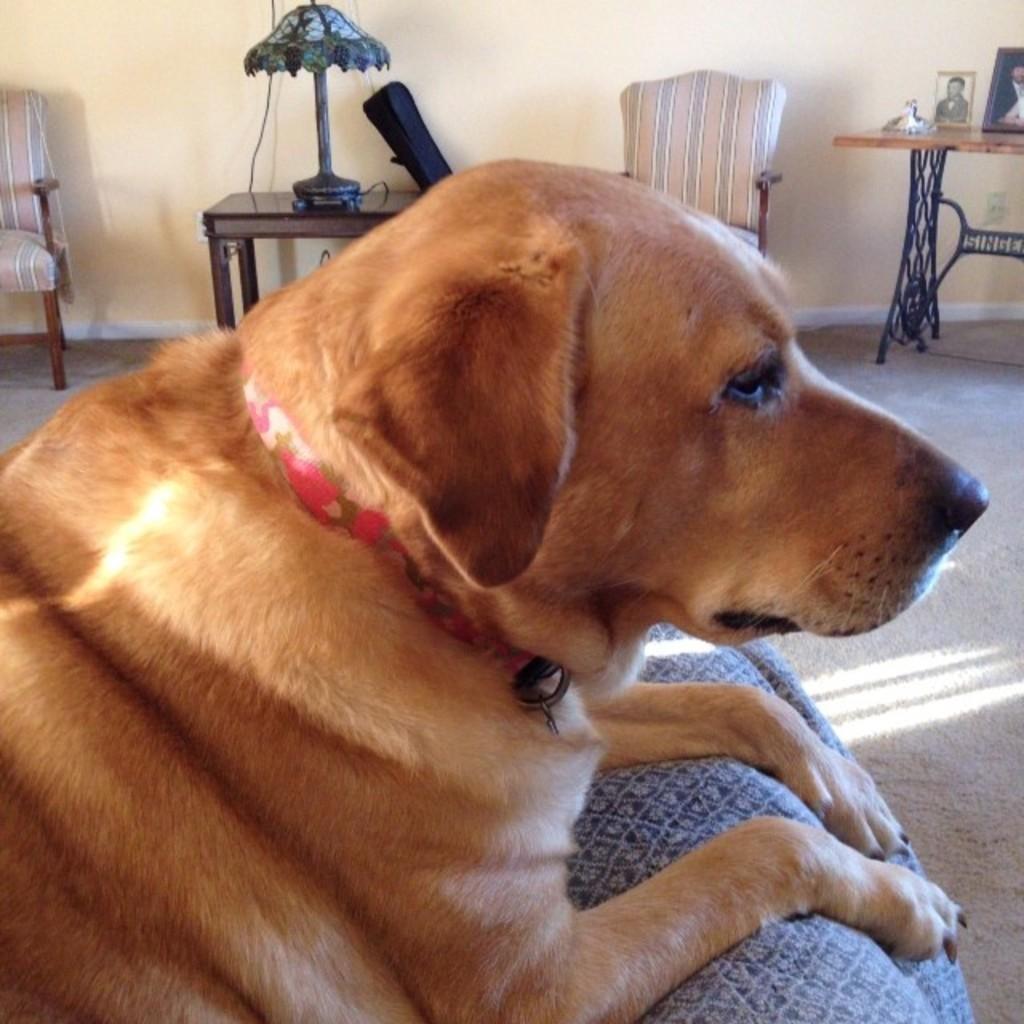Describe this image in one or two sentences. In this image we can see a dog on couch. In the background we can see chairs, table, lamp and photo frames on table. 